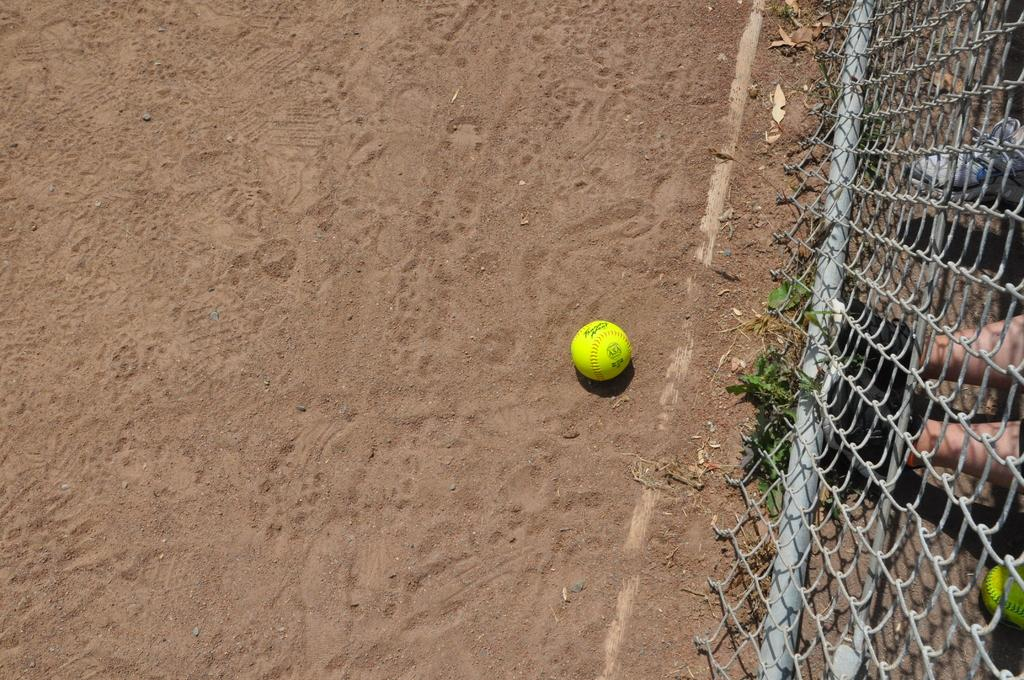What object is on the ground in the image? There is a ball on the ground in the image. What type of material is present in the image? There is a mesh in the image. What type of vegetation is present in the image? Leaves are present in the image. What part of a person can be seen through the mesh? A person's legs with footwear are visible through the mesh. What type of footwear is visible in the image? There is a shoe visible in the image. How many balls are visible in the image? There are two balls visible in the image. What direction is the lawyer walking on the bridge in the image? There is no lawyer or bridge present in the image. 